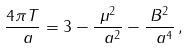<formula> <loc_0><loc_0><loc_500><loc_500>\frac { 4 \pi T } { \ a } = 3 - \frac { \mu ^ { 2 } } { \ a ^ { 2 } } - \frac { B ^ { 2 } } { \ a ^ { 4 } } \, ,</formula> 